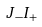Convert formula to latex. <formula><loc_0><loc_0><loc_500><loc_500>J _ { - } I _ { + }</formula> 